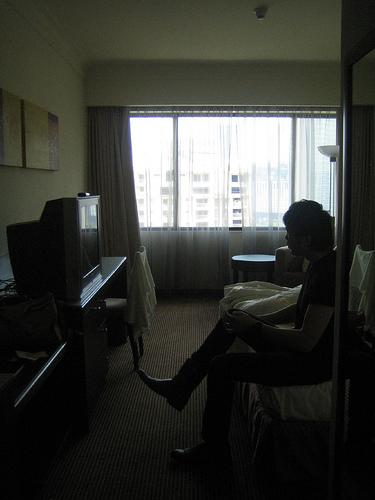Where is the woman sitting in?

Choices:
A) bedroom
B) office
C) hotel room
D) library hotel room 